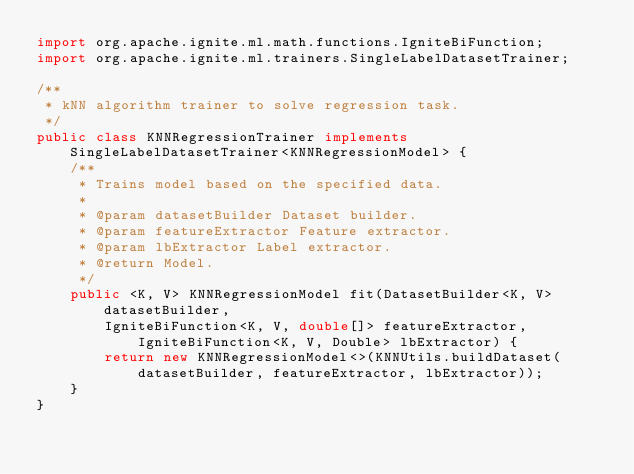<code> <loc_0><loc_0><loc_500><loc_500><_Java_>import org.apache.ignite.ml.math.functions.IgniteBiFunction;
import org.apache.ignite.ml.trainers.SingleLabelDatasetTrainer;

/**
 * kNN algorithm trainer to solve regression task.
 */
public class KNNRegressionTrainer implements SingleLabelDatasetTrainer<KNNRegressionModel> {
    /**
     * Trains model based on the specified data.
     *
     * @param datasetBuilder Dataset builder.
     * @param featureExtractor Feature extractor.
     * @param lbExtractor Label extractor.
     * @return Model.
     */
    public <K, V> KNNRegressionModel fit(DatasetBuilder<K, V> datasetBuilder,
        IgniteBiFunction<K, V, double[]> featureExtractor, IgniteBiFunction<K, V, Double> lbExtractor) {
        return new KNNRegressionModel<>(KNNUtils.buildDataset(datasetBuilder, featureExtractor, lbExtractor));
    }
}
</code> 